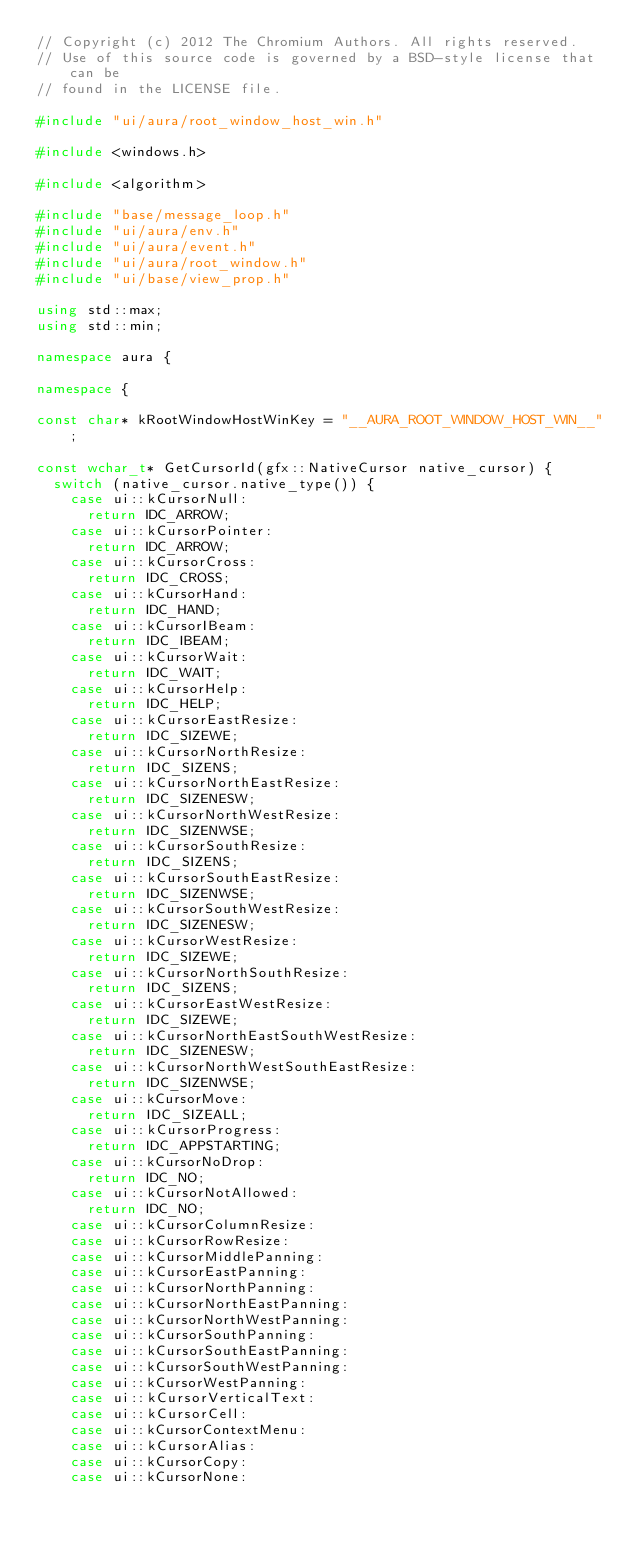<code> <loc_0><loc_0><loc_500><loc_500><_C++_>// Copyright (c) 2012 The Chromium Authors. All rights reserved.
// Use of this source code is governed by a BSD-style license that can be
// found in the LICENSE file.

#include "ui/aura/root_window_host_win.h"

#include <windows.h>

#include <algorithm>

#include "base/message_loop.h"
#include "ui/aura/env.h"
#include "ui/aura/event.h"
#include "ui/aura/root_window.h"
#include "ui/base/view_prop.h"

using std::max;
using std::min;

namespace aura {

namespace {

const char* kRootWindowHostWinKey = "__AURA_ROOT_WINDOW_HOST_WIN__";

const wchar_t* GetCursorId(gfx::NativeCursor native_cursor) {
  switch (native_cursor.native_type()) {
    case ui::kCursorNull:
      return IDC_ARROW;
    case ui::kCursorPointer:
      return IDC_ARROW;
    case ui::kCursorCross:
      return IDC_CROSS;
    case ui::kCursorHand:
      return IDC_HAND;
    case ui::kCursorIBeam:
      return IDC_IBEAM;
    case ui::kCursorWait:
      return IDC_WAIT;
    case ui::kCursorHelp:
      return IDC_HELP;
    case ui::kCursorEastResize:
      return IDC_SIZEWE;
    case ui::kCursorNorthResize:
      return IDC_SIZENS;
    case ui::kCursorNorthEastResize:
      return IDC_SIZENESW;
    case ui::kCursorNorthWestResize:
      return IDC_SIZENWSE;
    case ui::kCursorSouthResize:
      return IDC_SIZENS;
    case ui::kCursorSouthEastResize:
      return IDC_SIZENWSE;
    case ui::kCursorSouthWestResize:
      return IDC_SIZENESW;
    case ui::kCursorWestResize:
      return IDC_SIZEWE;
    case ui::kCursorNorthSouthResize:
      return IDC_SIZENS;
    case ui::kCursorEastWestResize:
      return IDC_SIZEWE;
    case ui::kCursorNorthEastSouthWestResize:
      return IDC_SIZENESW;
    case ui::kCursorNorthWestSouthEastResize:
      return IDC_SIZENWSE;
    case ui::kCursorMove:
      return IDC_SIZEALL;
    case ui::kCursorProgress:
      return IDC_APPSTARTING;
    case ui::kCursorNoDrop:
      return IDC_NO;
    case ui::kCursorNotAllowed:
      return IDC_NO;
    case ui::kCursorColumnResize:
    case ui::kCursorRowResize:
    case ui::kCursorMiddlePanning:
    case ui::kCursorEastPanning:
    case ui::kCursorNorthPanning:
    case ui::kCursorNorthEastPanning:
    case ui::kCursorNorthWestPanning:
    case ui::kCursorSouthPanning:
    case ui::kCursorSouthEastPanning:
    case ui::kCursorSouthWestPanning:
    case ui::kCursorWestPanning:
    case ui::kCursorVerticalText:
    case ui::kCursorCell:
    case ui::kCursorContextMenu:
    case ui::kCursorAlias:
    case ui::kCursorCopy:
    case ui::kCursorNone:</code> 